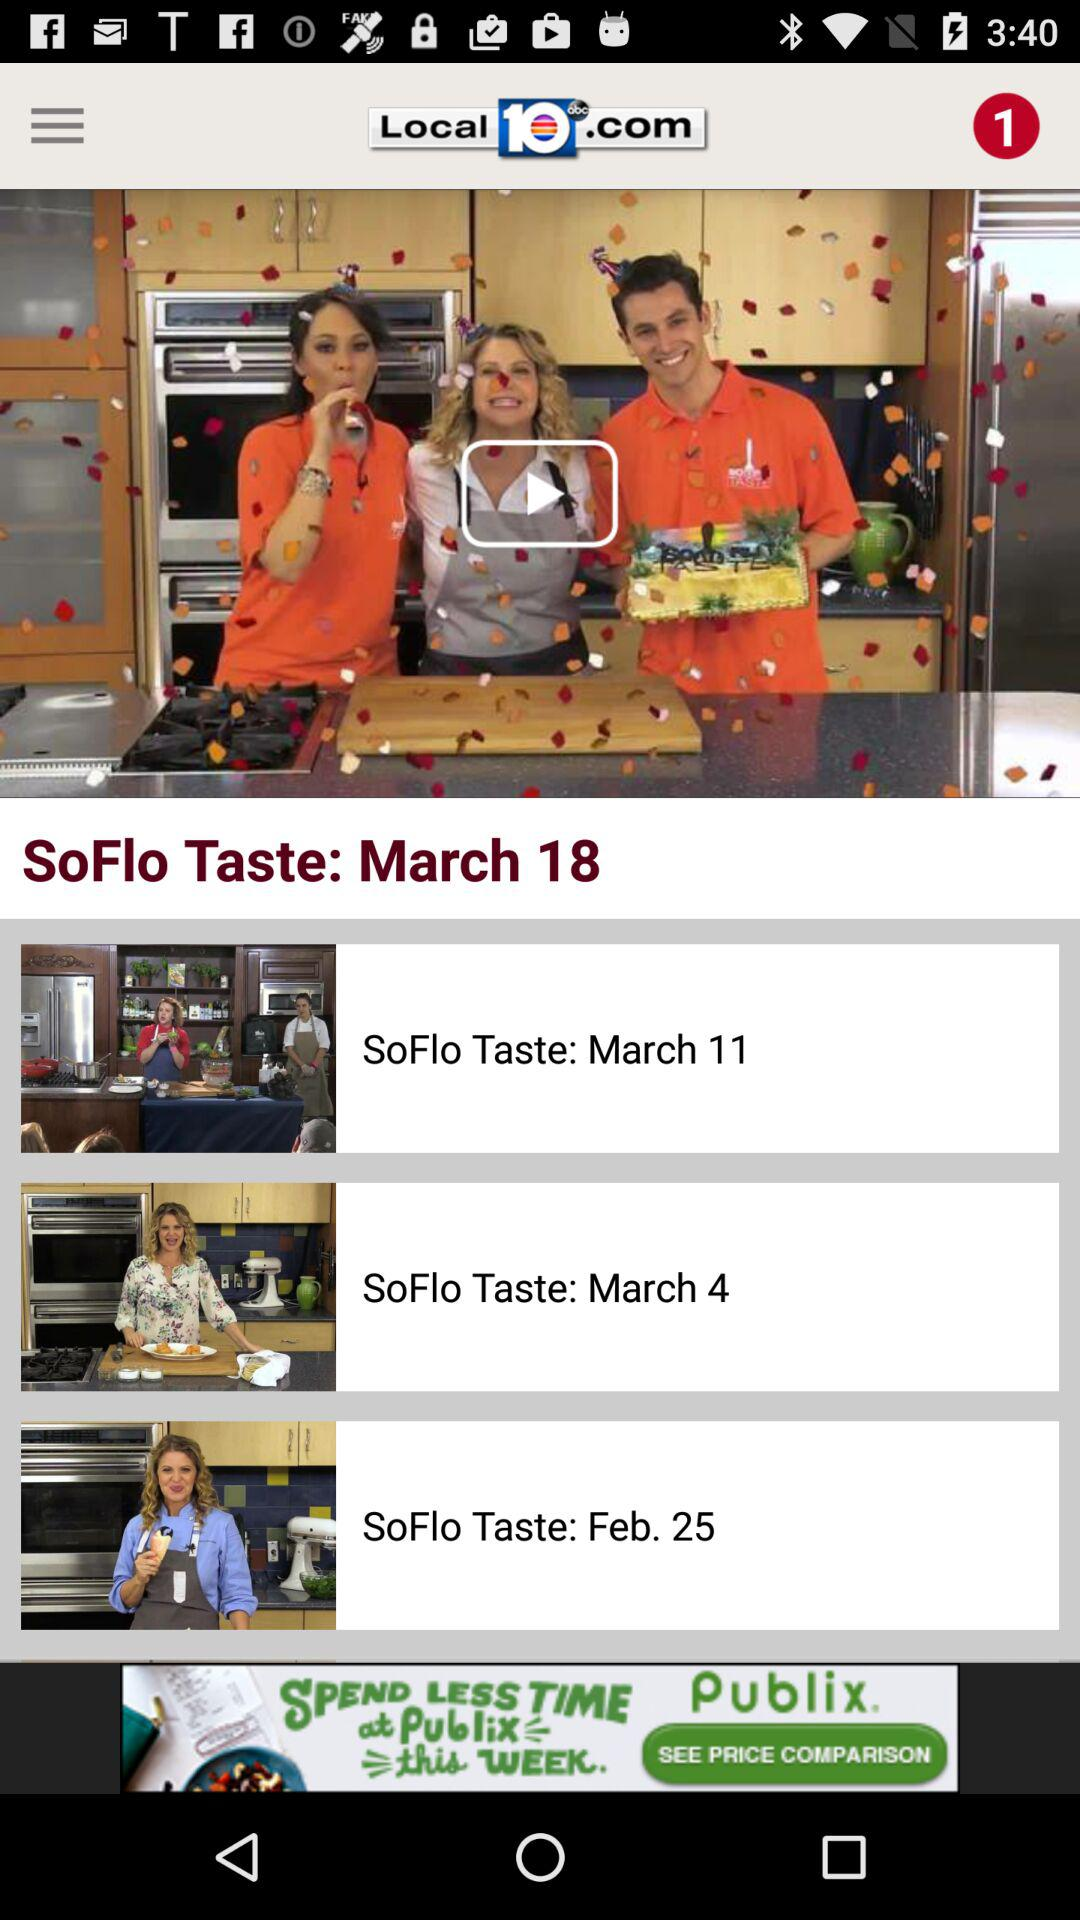What is the name of the channel? The name of the channel is "Local 10abc.com". 